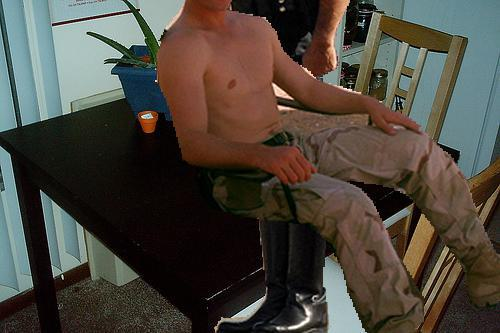Is there a diningtable in the image? Yes 